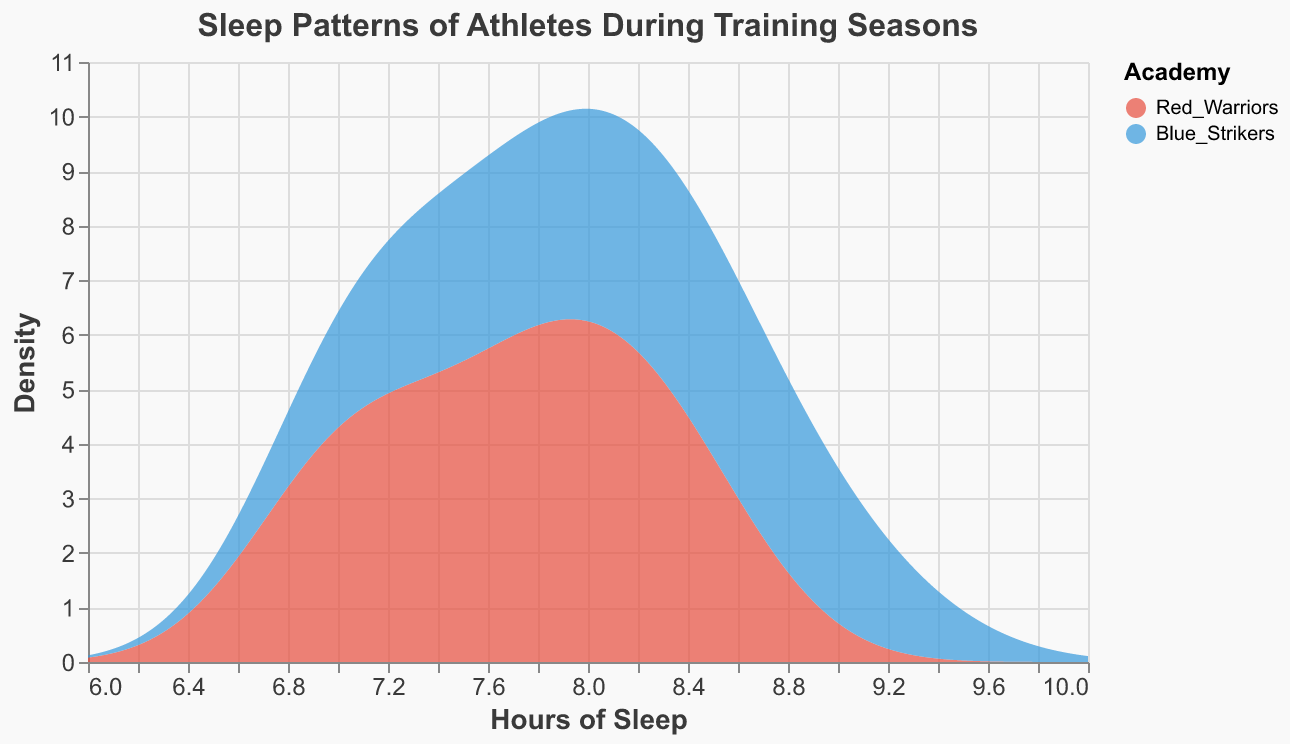What does the title of the plot indicate? The title of the plot indicates the main subject of the data visualization. It suggests the plot shows the sleep patterns of athletes during different training seasons.
Answer: Sleep Patterns of Athletes During Training Seasons Which two academies are being compared in this figure? The color legend and labels on the plot indicate the two academies involved. They are the "Red Warriors" and "Blue Strikers."
Answer: Red Warriors and Blue Strikers What is the variable measured on the x-axis? The label on the x-axis of the plot shows it measures "Hours of Sleep" which is a quantitative variable.
Answer: Hours of Sleep Which academy appears to have a higher density for hours of sleep around 8-9 hours? By observing the areas under the curves around the 8-9 hours range, the Blue Strikers' curve appears higher compared to the Red Warriors, indicating a higher density.
Answer: Blue Strikers During which part of the training season do athletes from the Red Warriors academy appear to have the least amount of sleep? Checking the density for different sleep hours and seasons, the smallest sleep duration is indicated by the end-season for Red Warriors. The spike around 7-8 hours of sleep shows a peak density in the end-season.
Answer: End-Season Which academy has more variability in athletes' sleep patterns overall? By looking at the spread and shape of the density curves, the Blue Strikers have a more varied spread over different hours of sleep, indicating greater variability.
Answer: Blue Strikers What is the range of hours of sleep for which the density of Blue Strikers is the highest? Observing the highest peaks in the density plot for Blue Strikers, it appears that the densest values fall around 8.5 to 9 hours of sleep.
Answer: 8.5-9 hours Are there any hours of sleep where both academies show similar density? By evaluating the overlapping regions of density plot lines, both academies show similar density around the 8-hour mark.
Answer: Around 8 hours Which academy shows a distinctive peak at 8 hours of sleep in the density plot? By observing the density plot peak, the Red Warriors show a distinctive peak around 8 hours of sleep which is clearly visible in the plot.
Answer: Red Warriors Does the plot indicate any season where sleep patterns are less varied for a specific academy? Assessing the density plots, the regular season for Blue Strikers shows less variability in hours of sleep, indicated by a sharper peak and narrower spread.
Answer: Regular Season for Blue Strikers 